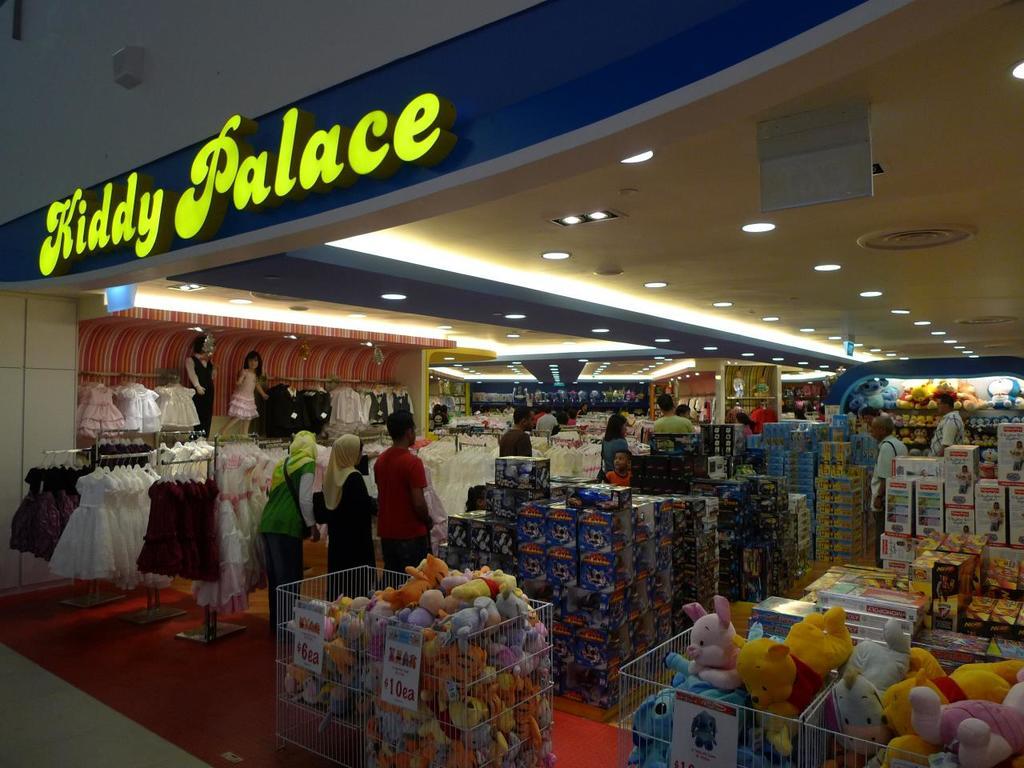What is the name of this store?
Ensure brevity in your answer.  Kiddy palace. What is the lowest price of the plushies being sold in the front?
Your answer should be very brief. 6. 